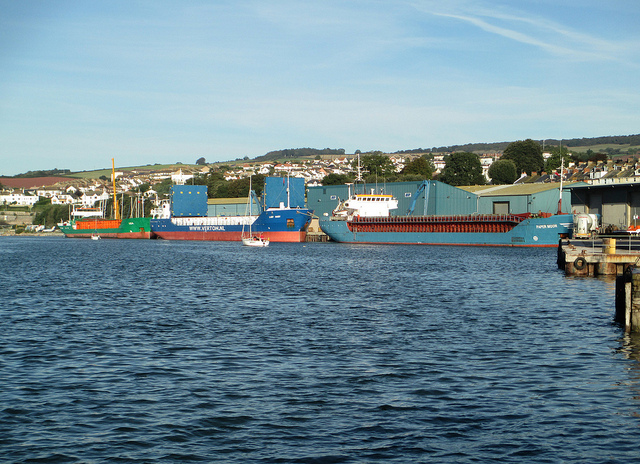<image>Which way is the wind blowing? It is ambiguous which way the wind is blowing. The answers suggest it could be east, north, to the right, or to the left. Which way is the wind blowing? I don't know which way the wind is blowing. It can be blowing to the north, east, or the left. 